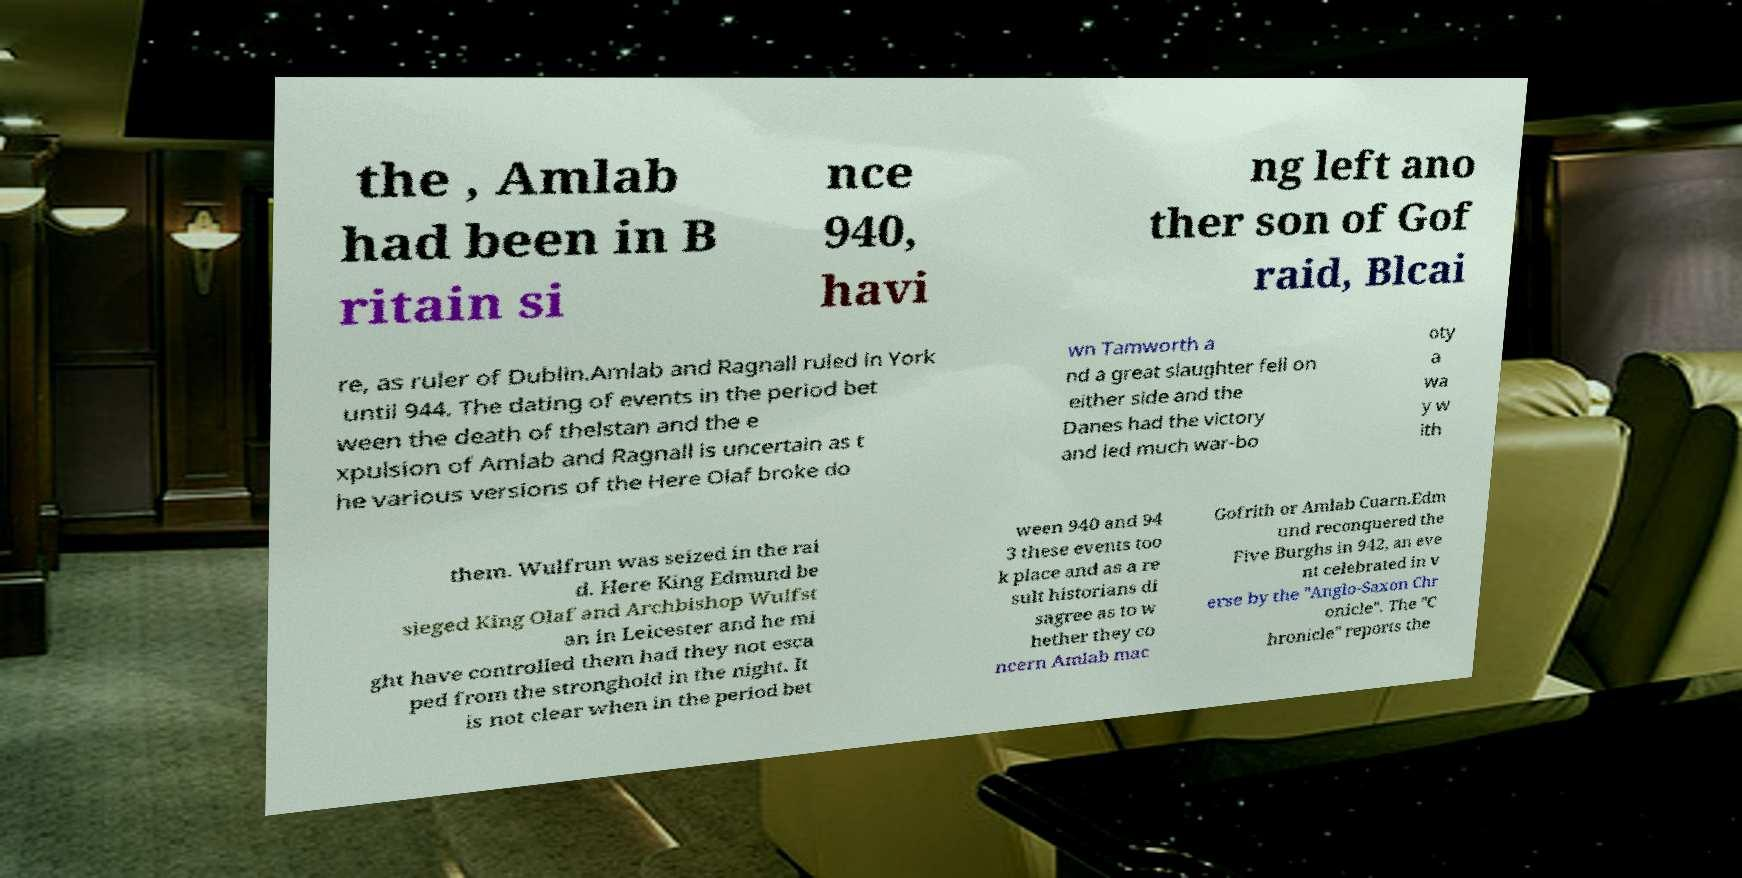What messages or text are displayed in this image? I need them in a readable, typed format. the , Amlab had been in B ritain si nce 940, havi ng left ano ther son of Gof raid, Blcai re, as ruler of Dublin.Amlab and Ragnall ruled in York until 944. The dating of events in the period bet ween the death of thelstan and the e xpulsion of Amlab and Ragnall is uncertain as t he various versions of the Here Olaf broke do wn Tamworth a nd a great slaughter fell on either side and the Danes had the victory and led much war-bo oty a wa y w ith them. Wulfrun was seized in the rai d. Here King Edmund be sieged King Olaf and Archbishop Wulfst an in Leicester and he mi ght have controlled them had they not esca ped from the stronghold in the night. It is not clear when in the period bet ween 940 and 94 3 these events too k place and as a re sult historians di sagree as to w hether they co ncern Amlab mac Gofrith or Amlab Cuarn.Edm und reconquered the Five Burghs in 942, an eve nt celebrated in v erse by the "Anglo-Saxon Chr onicle". The "C hronicle" reports the 